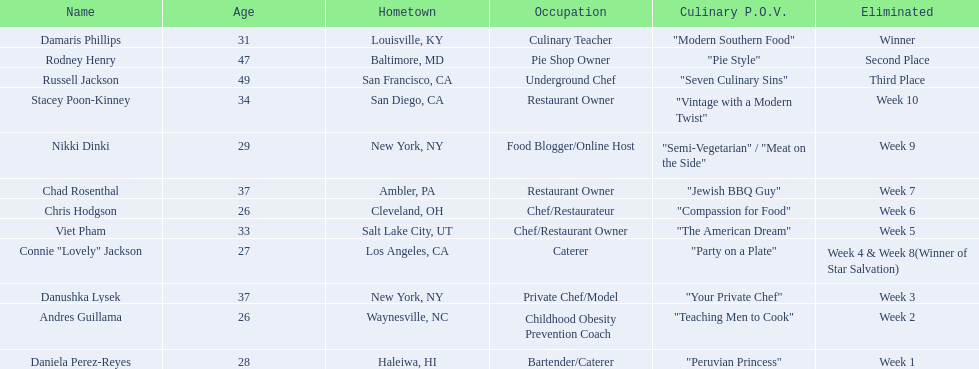Who are all the participants? Damaris Phillips, Rodney Henry, Russell Jackson, Stacey Poon-Kinney, Nikki Dinki, Chad Rosenthal, Chris Hodgson, Viet Pham, Connie "Lovely" Jackson, Danushka Lysek, Andres Guillama, Daniela Perez-Reyes. What is each contestant's food-related point of view? "Modern Southern Food", "Pie Style", "Seven Culinary Sins", "Vintage with a Modern Twist", "Semi-Vegetarian" / "Meat on the Side", "Jewish BBQ Guy", "Compassion for Food", "The American Dream", "Party on a Plate", "Your Private Chef", "Teaching Men to Cook", "Peruvian Princess". And whose point of view has the greatest length? Nikki Dinki. 